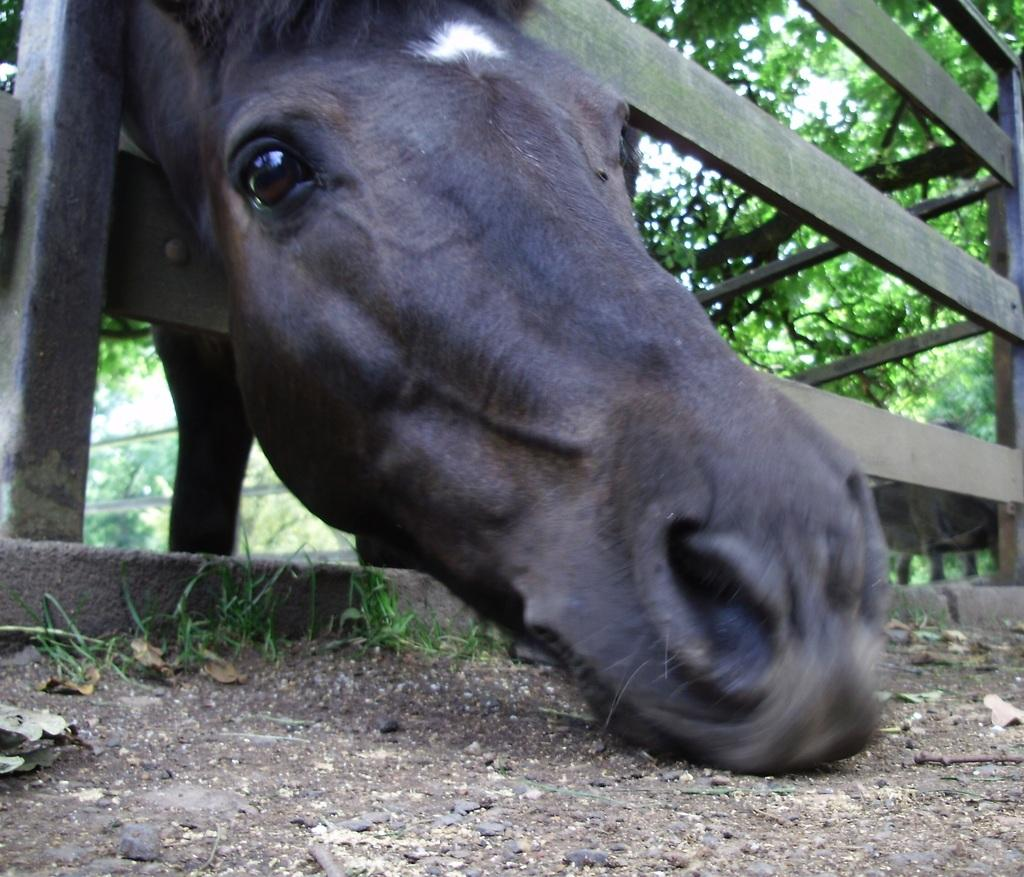What is mounted on the fence in the image? There is an animal head visible on the fence. What type of vegetation can be seen at the top of the image? There are trees at the top of the image. What type of boats are visible in the image? There are no boats present in the image; it only features an animal head on the fence and trees at the top. 